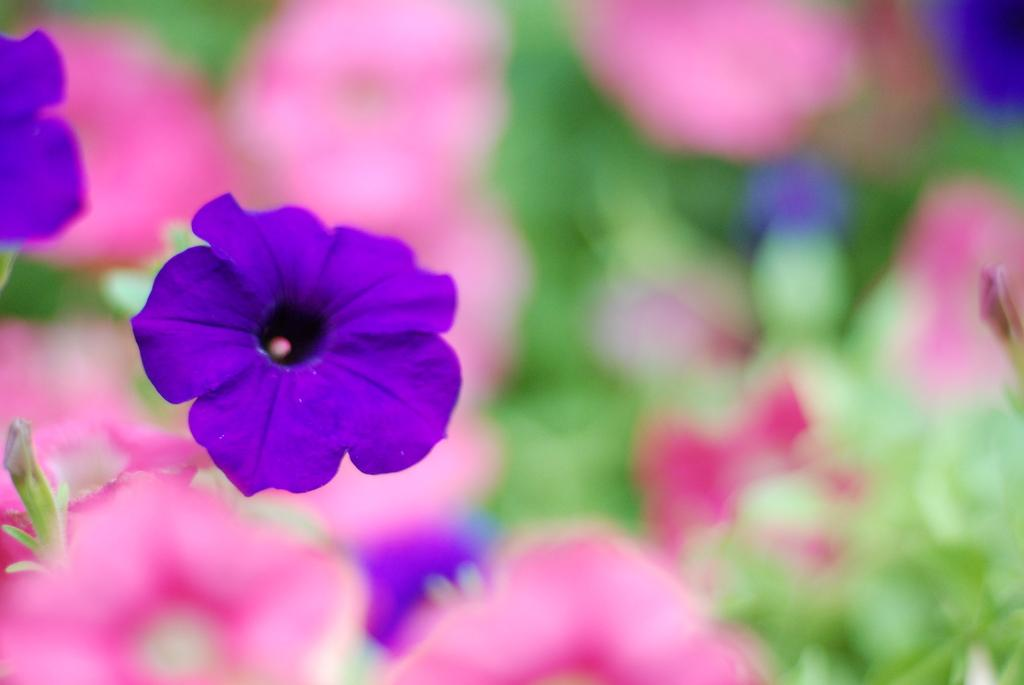What type of living organisms can be seen in the image? Flowers and plants can be seen in the image. Can you describe the plants in the image? The plants in the image are flowers. What type of toy can be seen in the image? There is no toy present in the image; it features flowers and plants. What type of garden is visible in the image? There is no garden present in the image; it features flowers and plants. 